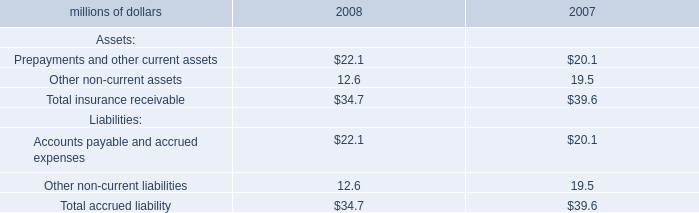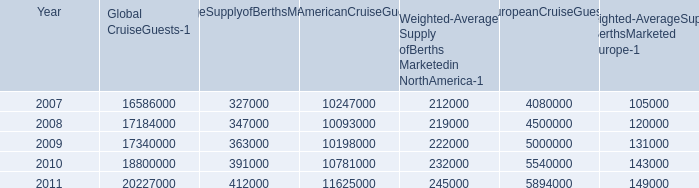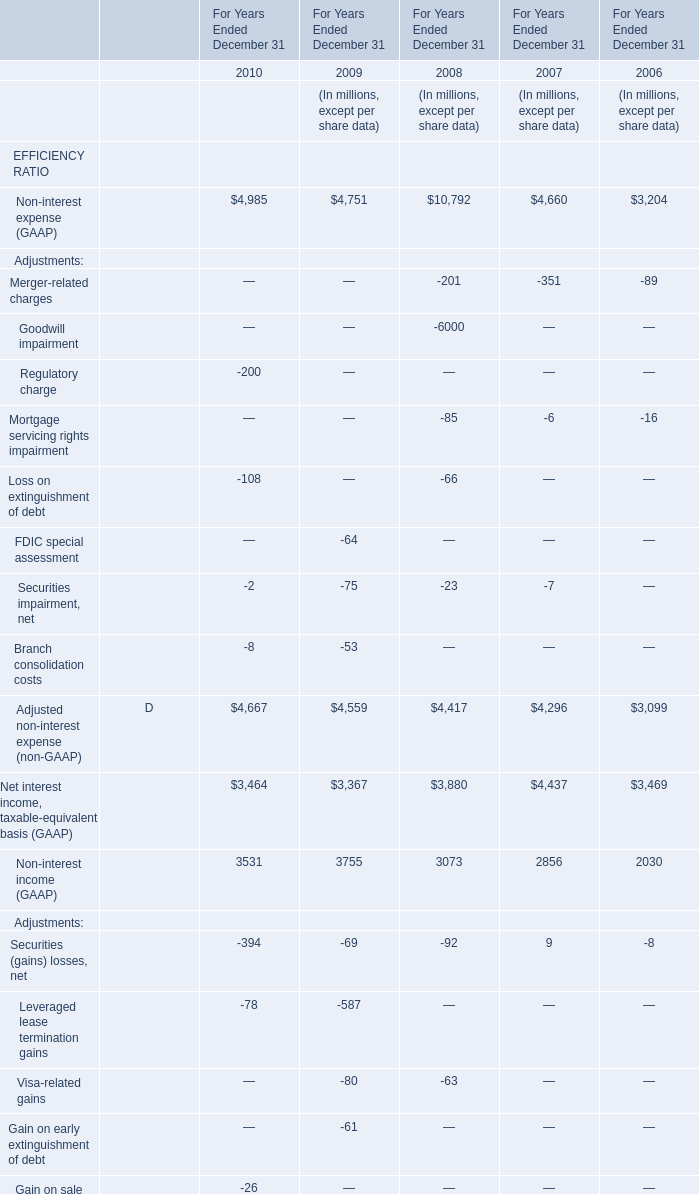What's the average of Non-interest expense (GAAP) in 2010 and 2009? 
Computations: ((4985 + 4751) / 2)
Answer: 4868.0. 